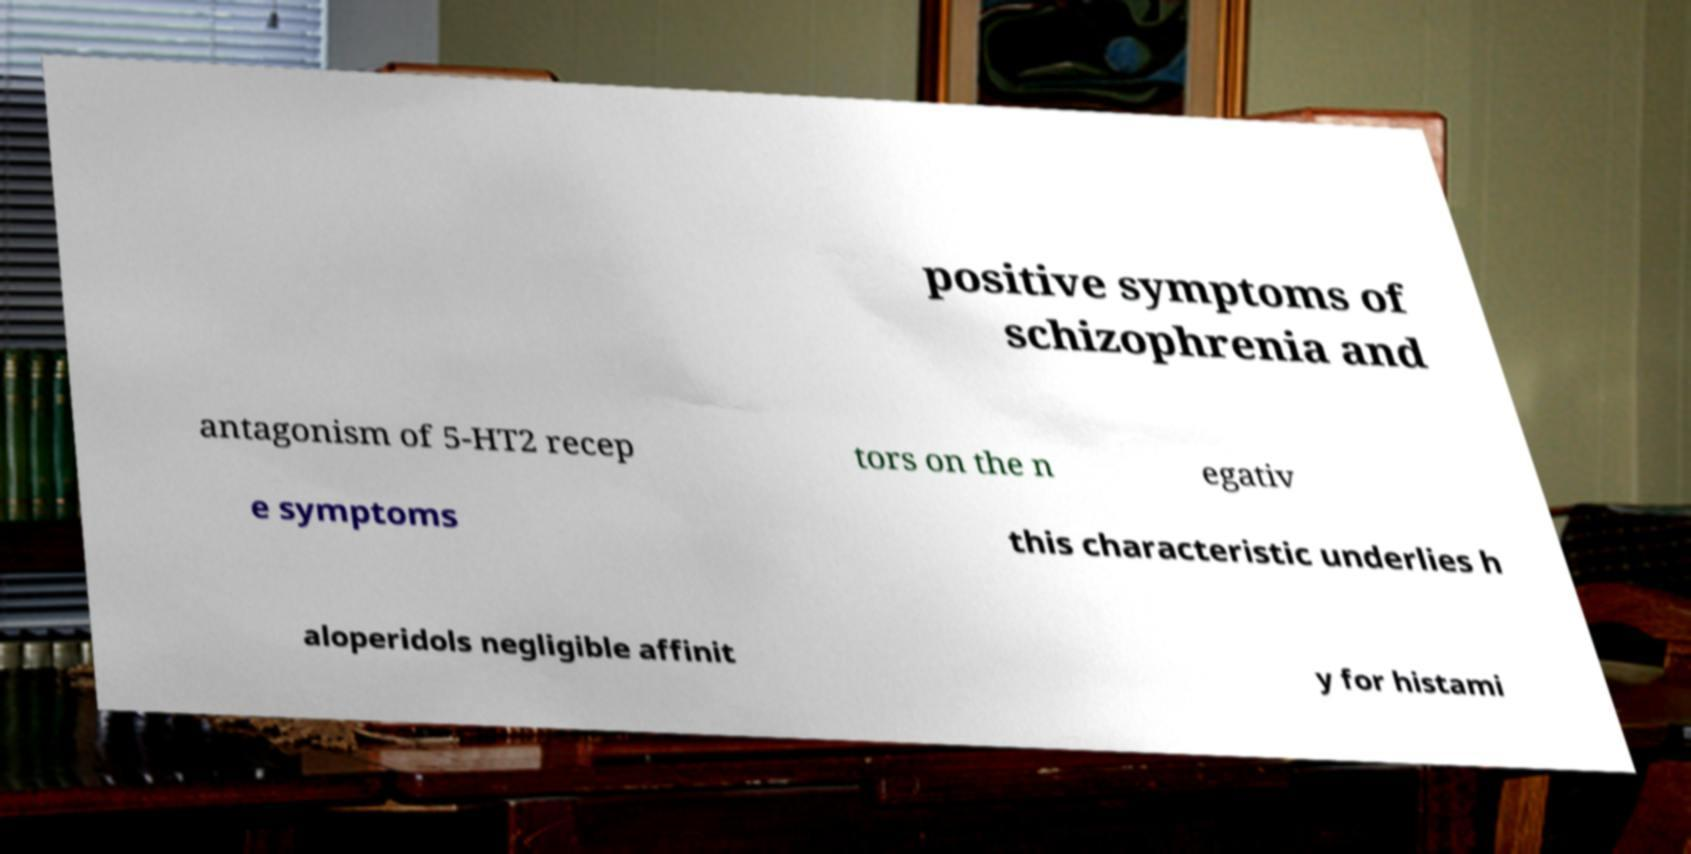Could you assist in decoding the text presented in this image and type it out clearly? positive symptoms of schizophrenia and antagonism of 5-HT2 recep tors on the n egativ e symptoms this characteristic underlies h aloperidols negligible affinit y for histami 